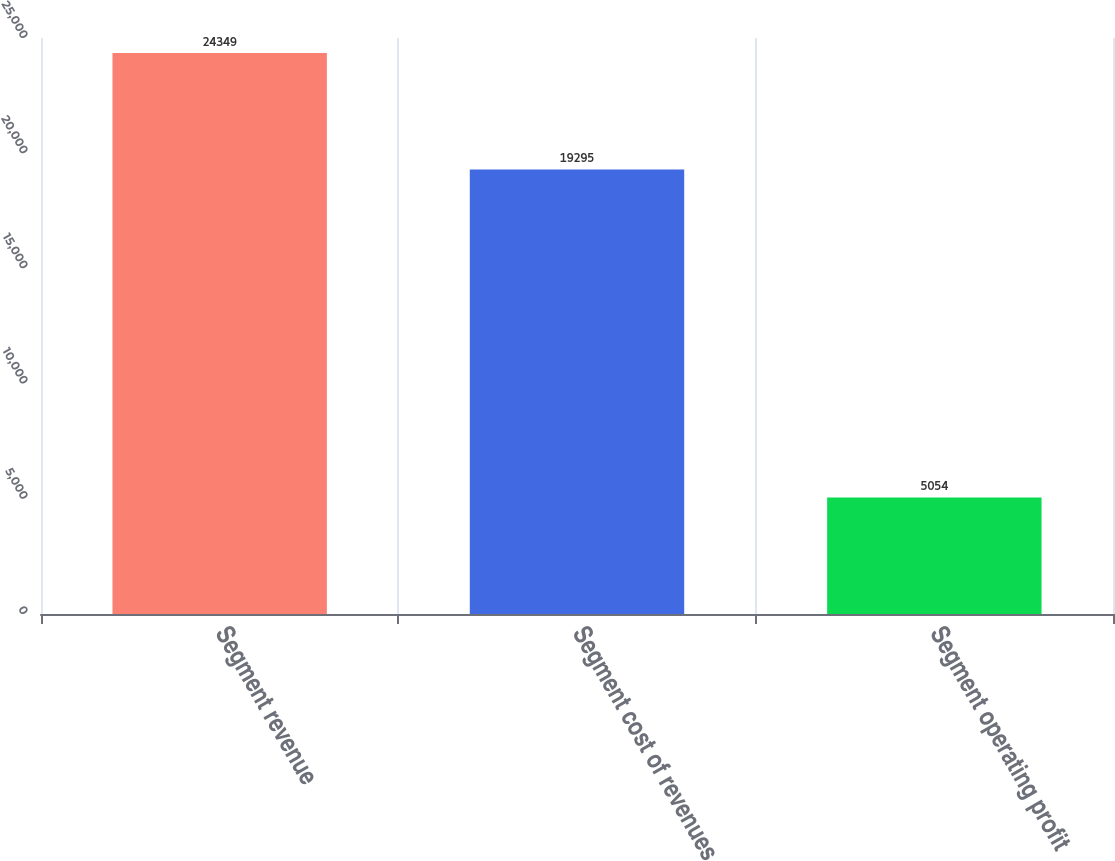Convert chart to OTSL. <chart><loc_0><loc_0><loc_500><loc_500><bar_chart><fcel>Segment revenue<fcel>Segment cost of revenues<fcel>Segment operating profit<nl><fcel>24349<fcel>19295<fcel>5054<nl></chart> 